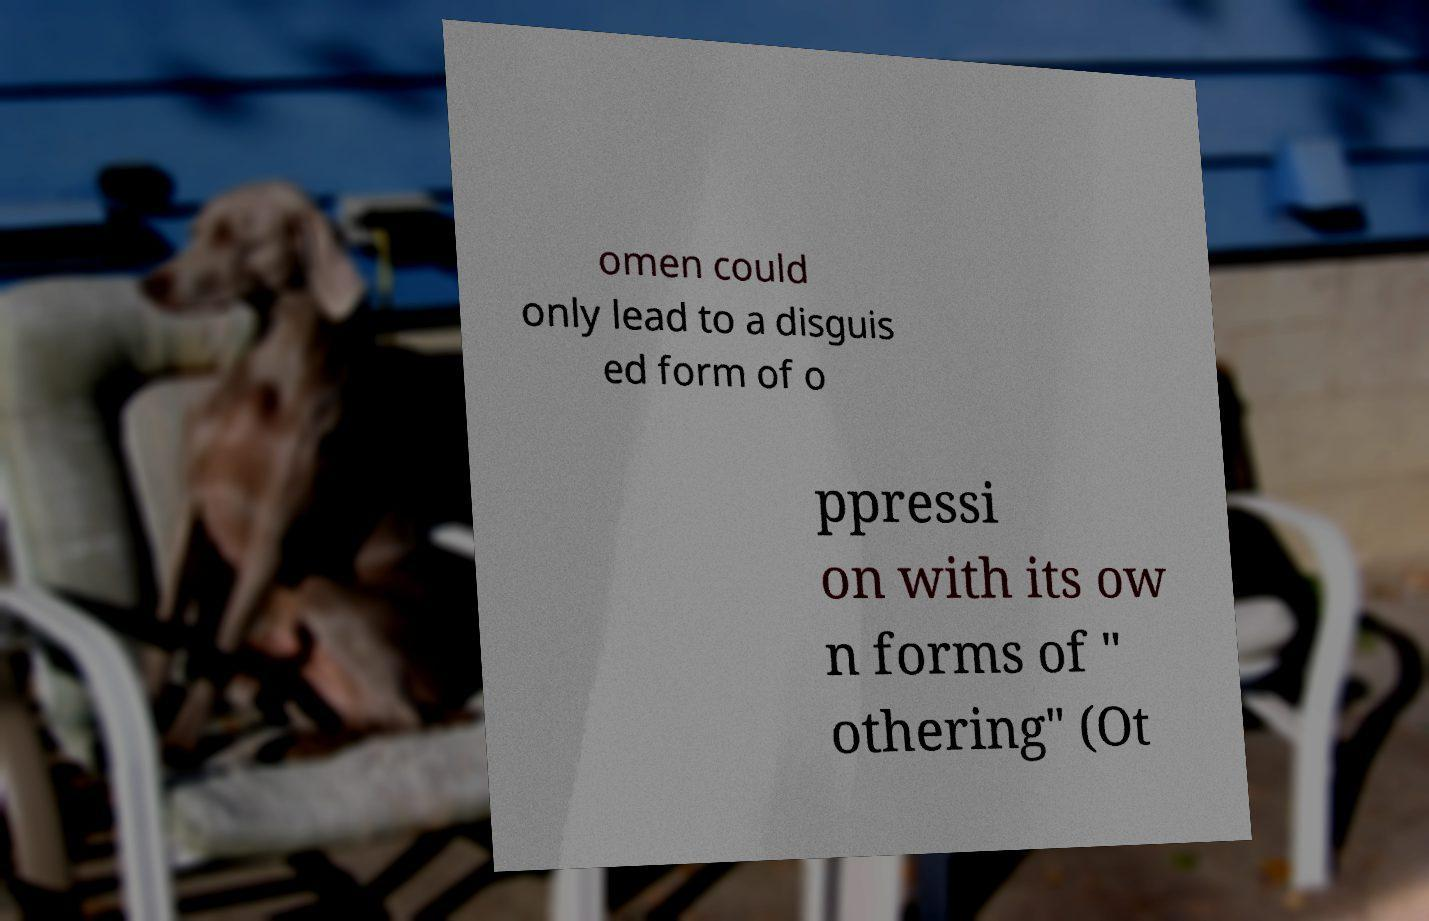Can you accurately transcribe the text from the provided image for me? omen could only lead to a disguis ed form of o ppressi on with its ow n forms of " othering" (Ot 